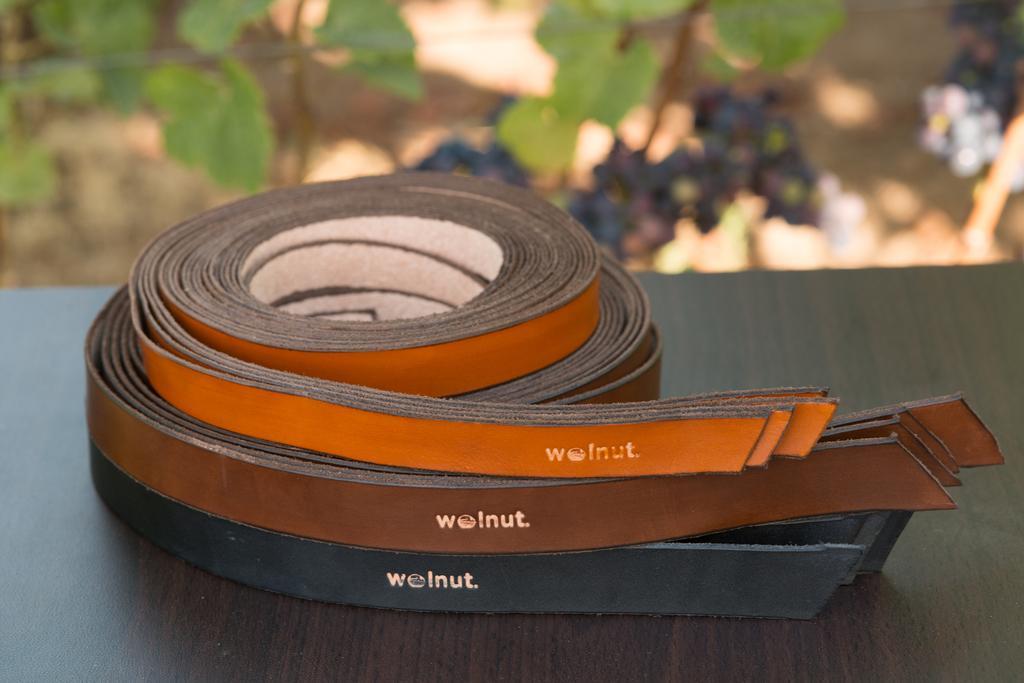In one or two sentences, can you explain what this image depicts? In this image, I can see the leather belts, which are black, brown and orange in color. These boots are placed on the wooden platform. In the background, I can see the plants. 